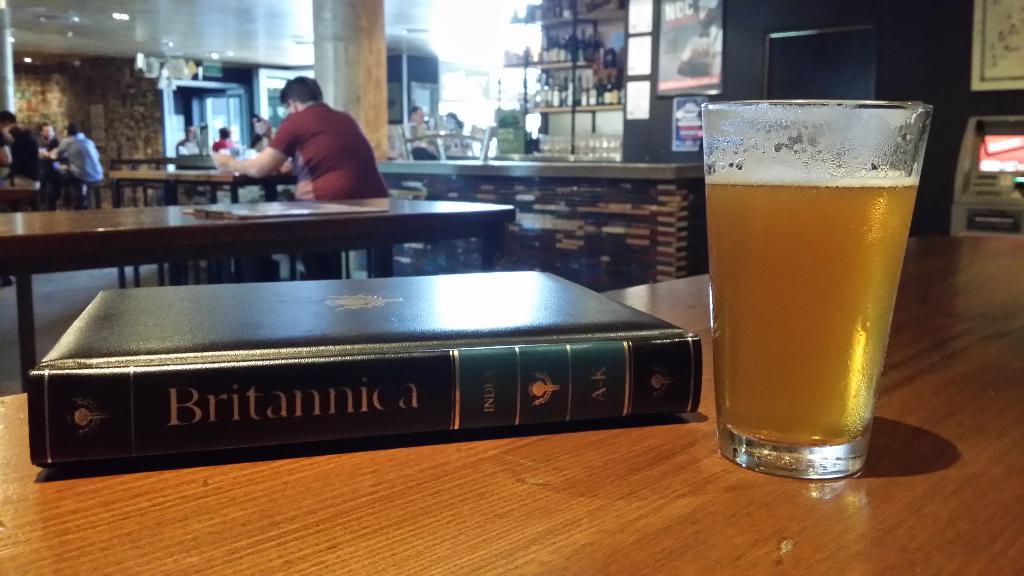What is the name of the book on the table next to the beer?
Provide a succinct answer. Britannica. What letters of the books are shown on this book?
Your response must be concise. A-k. 